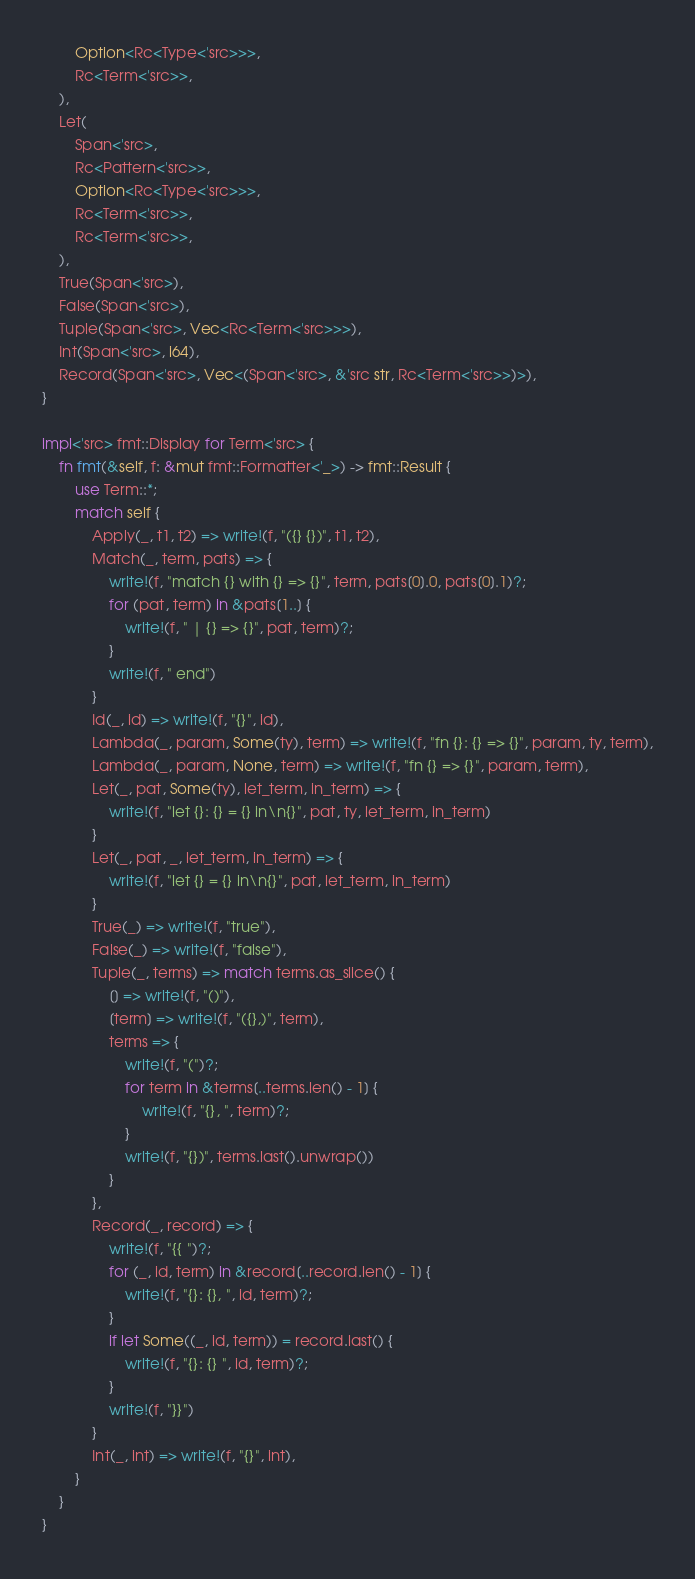Convert code to text. <code><loc_0><loc_0><loc_500><loc_500><_Rust_>        Option<Rc<Type<'src>>>,
        Rc<Term<'src>>,
    ),
    Let(
        Span<'src>,
        Rc<Pattern<'src>>,
        Option<Rc<Type<'src>>>,
        Rc<Term<'src>>,
        Rc<Term<'src>>,
    ),
    True(Span<'src>),
    False(Span<'src>),
    Tuple(Span<'src>, Vec<Rc<Term<'src>>>),
    Int(Span<'src>, i64),
    Record(Span<'src>, Vec<(Span<'src>, &'src str, Rc<Term<'src>>)>),
}

impl<'src> fmt::Display for Term<'src> {
    fn fmt(&self, f: &mut fmt::Formatter<'_>) -> fmt::Result {
        use Term::*;
        match self {
            Apply(_, t1, t2) => write!(f, "({} {})", t1, t2),
            Match(_, term, pats) => {
                write!(f, "match {} with {} => {}", term, pats[0].0, pats[0].1)?;
                for (pat, term) in &pats[1..] {
                    write!(f, " | {} => {}", pat, term)?;
                }
                write!(f, " end")
            }
            Id(_, id) => write!(f, "{}", id),
            Lambda(_, param, Some(ty), term) => write!(f, "fn {}: {} => {}", param, ty, term),
            Lambda(_, param, None, term) => write!(f, "fn {} => {}", param, term),
            Let(_, pat, Some(ty), let_term, in_term) => {
                write!(f, "let {}: {} = {} in\n{}", pat, ty, let_term, in_term)
            }
            Let(_, pat, _, let_term, in_term) => {
                write!(f, "let {} = {} in\n{}", pat, let_term, in_term)
            }
            True(_) => write!(f, "true"),
            False(_) => write!(f, "false"),
            Tuple(_, terms) => match terms.as_slice() {
                [] => write!(f, "()"),
                [term] => write!(f, "({},)", term),
                terms => {
                    write!(f, "(")?;
                    for term in &terms[..terms.len() - 1] {
                        write!(f, "{}, ", term)?;
                    }
                    write!(f, "{})", terms.last().unwrap())
                }
            },
            Record(_, record) => {
                write!(f, "{{ ")?;
                for (_, id, term) in &record[..record.len() - 1] {
                    write!(f, "{}: {}, ", id, term)?;
                }
                if let Some((_, id, term)) = record.last() {
                    write!(f, "{}: {} ", id, term)?;
                }
                write!(f, "}}")
            }
            Int(_, int) => write!(f, "{}", int),
        }
    }
}
</code> 